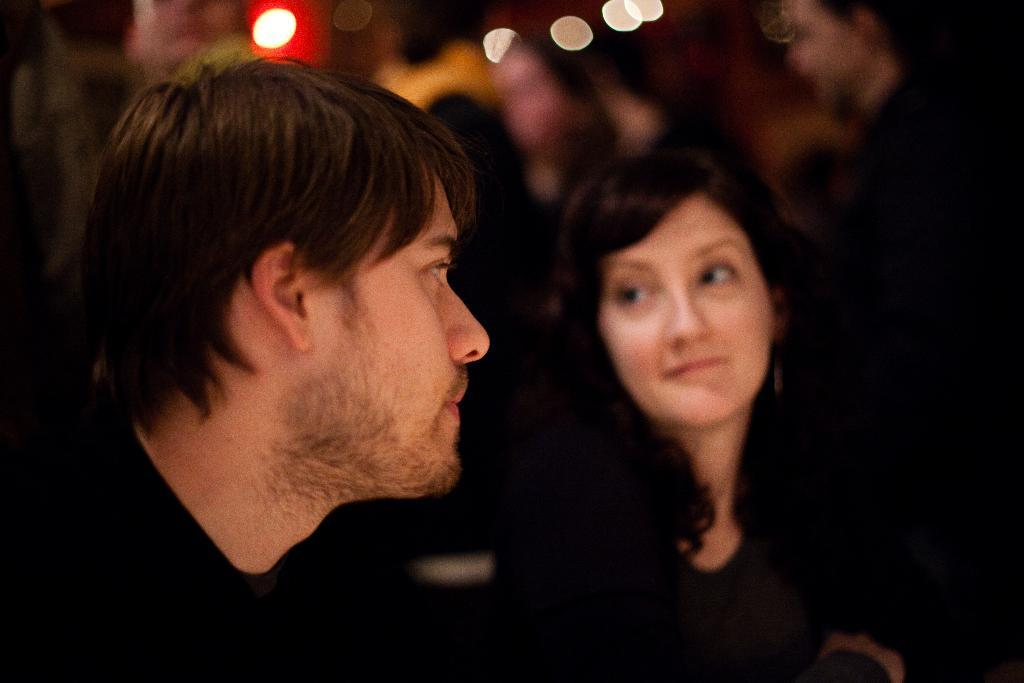How many people are present in the image? There are three people in the image: two men and a woman. Can you describe the lighting in the image? There are lights towards the top of the image. What can be said about the background of the image? The background of the image is blurred. What type of reaction does the snail have to the lights in the image? There is no snail present in the image, so it cannot have a reaction to the lights. 